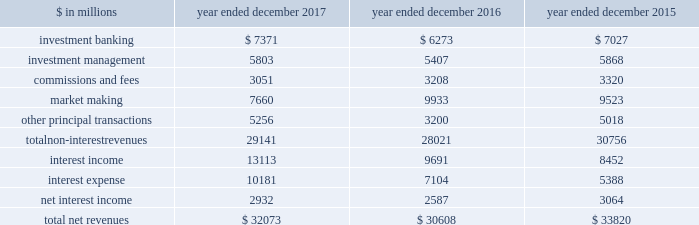The goldman sachs group , inc .
And subsidiaries management 2019s discussion and analysis net revenues the table below presents our net revenues by line item in the consolidated statements of earnings. .
In the table above : 2030 investment banking consists of revenues ( excluding net interest ) from financial advisory and underwriting assignments , as well as derivative transactions directly related to these assignments .
These activities are included in our investment banking segment .
2030 investment management consists of revenues ( excluding net interest ) from providing investment management services to a diverse set of clients , as well as wealth advisory services and certain transaction services to high-net-worth individuals and families .
These activities are included in our investment management segment .
2030 commissions and fees consists of revenues from executing and clearing client transactions on major stock , options and futures exchanges worldwide , as well as over-the-counter ( otc ) transactions .
These activities are included in our institutional client services and investment management segments .
2030 market making consists of revenues ( excluding net interest ) from client execution activities related to making markets in interest rate products , credit products , mortgages , currencies , commodities and equity products .
These activities are included in our institutional client services segment .
2030 other principal transactions consists of revenues ( excluding net interest ) from our investing activities and the origination of loans to provide financing to clients .
In addition , other principal transactions includes revenues related to our consolidated investments .
These activities are included in our investing & lending segment .
Operating environment .
During 2017 , generally higher asset prices and tighter credit spreads were supportive of industry-wide underwriting activities , investment management performance and other principal transactions .
However , low levels of volatility in equity , fixed income , currency and commodity markets continued to negatively affect our market-making activities , particularly in fixed income , currency and commodity products .
The price of natural gas decreased significantly during 2017 , while the price of oil increased compared with the end of 2016 .
If the trend of low volatility continues over the long term and market-making activity levels remain low , or if investment banking activity levels , asset prices or assets under supervision decline , net revenues would likely be negatively impacted .
See 201csegment operating results 201d below for further information about the operating environment and material trends and uncertainties that may impact our results of operations .
The first half of 2016 included challenging trends in the operating environment for our business activities including concerns and uncertainties about global economic growth , central bank activity and the political uncertainty and economic implications surrounding the potential exit of the u.k .
From the e.u .
During the second half of 2016 , the operating environment improved , as global equity markets steadily increased and investment grade and high-yield credit spreads tightened .
These trends provided a more favorable backdrop for our business activities .
2017 versus 2016 net revenues in the consolidated statements of earnings were $ 32.07 billion for 2017 , 5% ( 5 % ) higher than 2016 , due to significantly higher other principal transactions revenues , and higher investment banking revenues , investment management revenues and net interest income .
These increases were partially offset by significantly lower market making revenues and lower commissions and fees .
Non-interest revenues .
Investment banking revenues in the consolidated statements of earnings were $ 7.37 billion for 2017 , 18% ( 18 % ) higher than 2016 .
Revenues in financial advisory were higher compared with 2016 , reflecting an increase in completed mergers and acquisitions transactions .
Revenues in underwriting were significantly higher compared with 2016 , due to significantly higher revenues in both debt underwriting , primarily reflecting an increase in industry-wide leveraged finance activity , and equity underwriting , reflecting an increase in industry-wide secondary offerings .
52 goldman sachs 2017 form 10-k .
What is the growth rate in net revenues in 2017? 
Computations: ((32073 - 30608) / 30608)
Answer: 0.04786. 